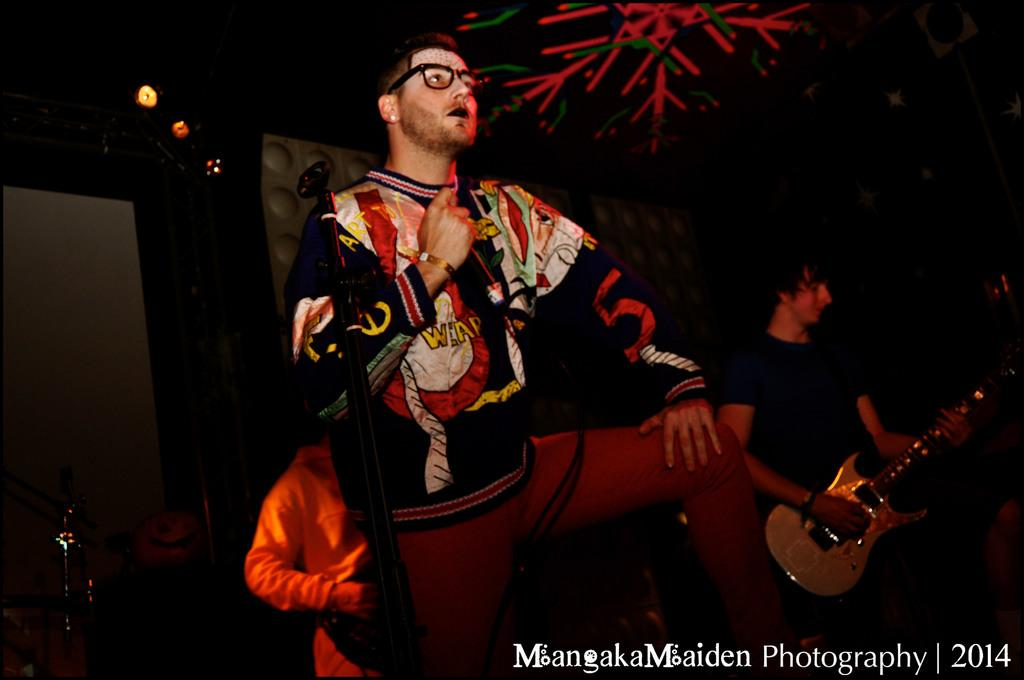Who is the main subject in the image? There is a person in the image. Can you describe the person's attire? The person is wearing a dress with different colors. What is happening in the background of the image? There are people playing musical instruments in the background. What is the color of the background? The background color is black. What type of quilt is being used to muffle the noise in the image? There is no quilt or noise present in the image. 